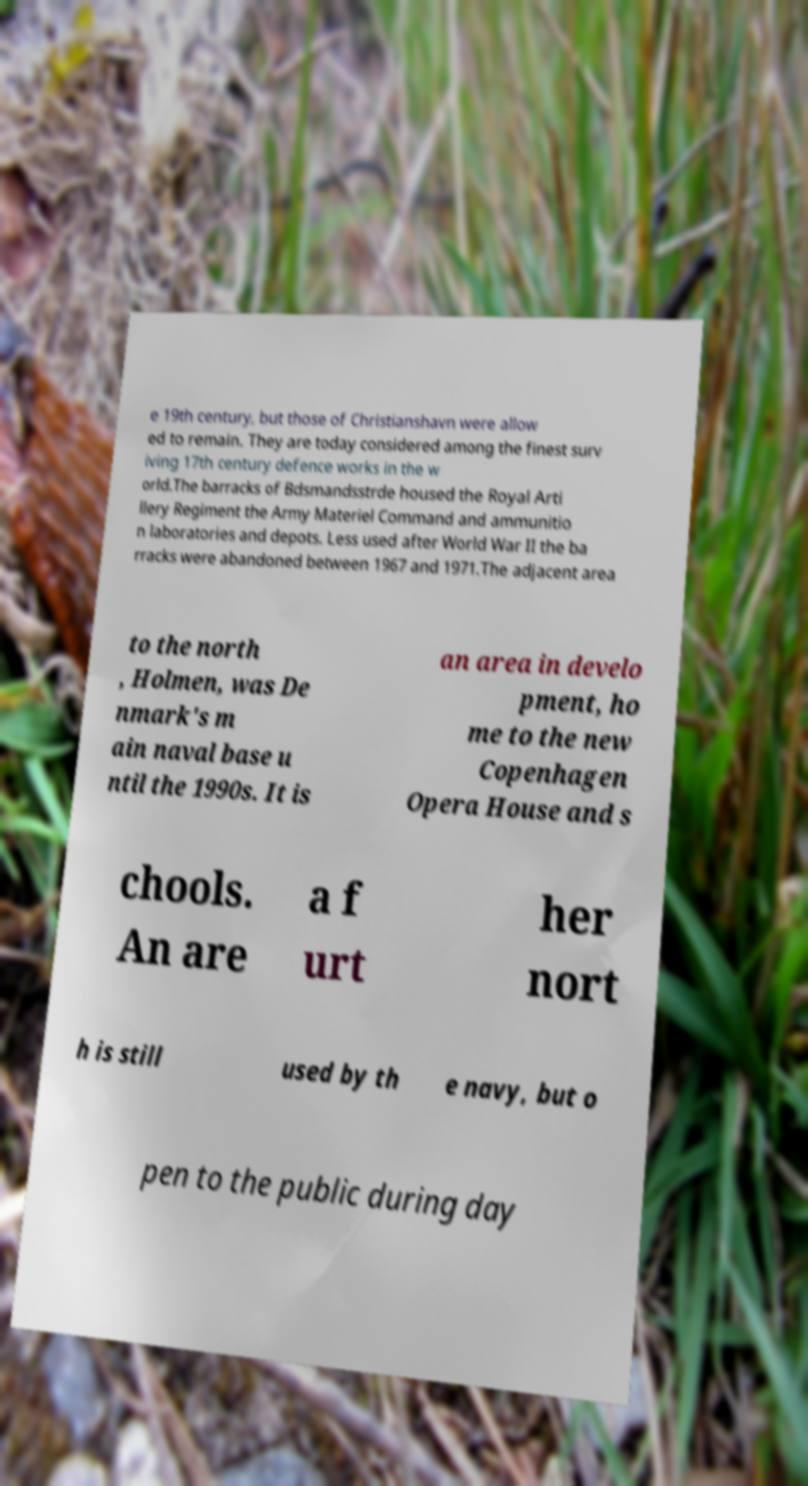Please identify and transcribe the text found in this image. e 19th century, but those of Christianshavn were allow ed to remain. They are today considered among the finest surv iving 17th century defence works in the w orld.The barracks of Bdsmandsstrde housed the Royal Arti llery Regiment the Army Materiel Command and ammunitio n laboratories and depots. Less used after World War II the ba rracks were abandoned between 1967 and 1971.The adjacent area to the north , Holmen, was De nmark's m ain naval base u ntil the 1990s. It is an area in develo pment, ho me to the new Copenhagen Opera House and s chools. An are a f urt her nort h is still used by th e navy, but o pen to the public during day 